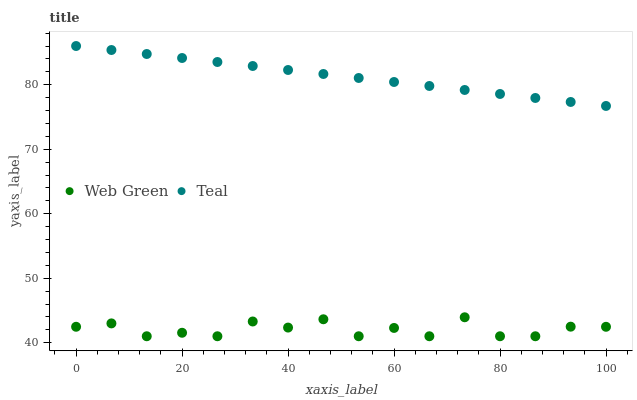Does Web Green have the minimum area under the curve?
Answer yes or no. Yes. Does Teal have the maximum area under the curve?
Answer yes or no. Yes. Does Web Green have the maximum area under the curve?
Answer yes or no. No. Is Teal the smoothest?
Answer yes or no. Yes. Is Web Green the roughest?
Answer yes or no. Yes. Is Web Green the smoothest?
Answer yes or no. No. Does Web Green have the lowest value?
Answer yes or no. Yes. Does Teal have the highest value?
Answer yes or no. Yes. Does Web Green have the highest value?
Answer yes or no. No. Is Web Green less than Teal?
Answer yes or no. Yes. Is Teal greater than Web Green?
Answer yes or no. Yes. Does Web Green intersect Teal?
Answer yes or no. No. 